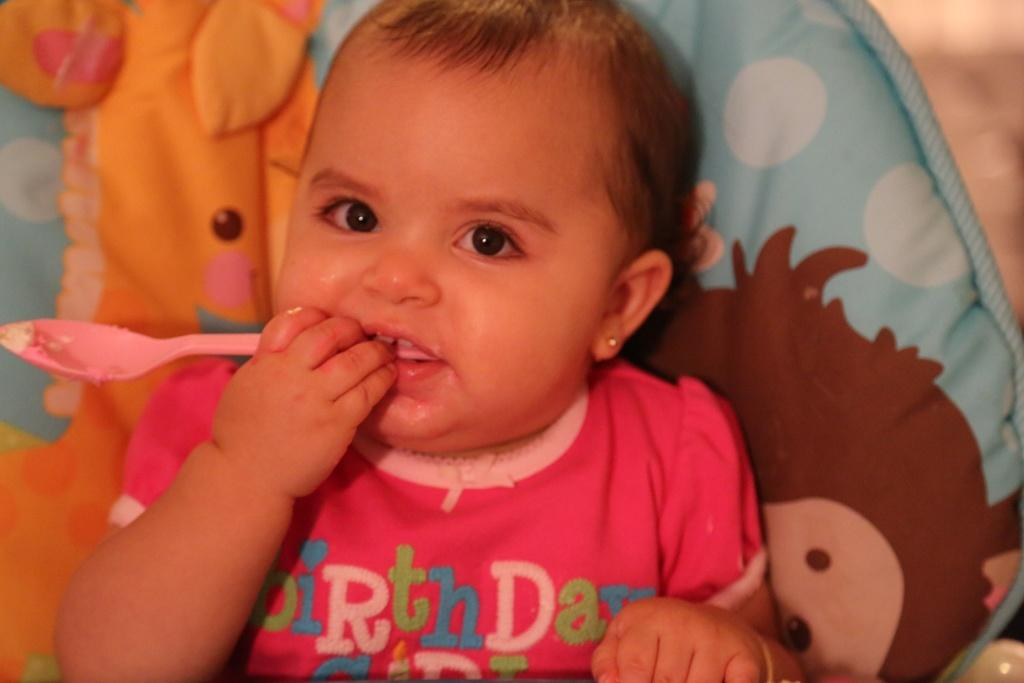What object is present in the image that is not a person? There is a cloth in the image. Who is present in the image? There is a girl in the image. What is the girl holding in her hand? The girl is holding a spoon in her hand. How would you describe the background of the image? The background of the image is blurry. What type of noise can be heard coming from the girl's legs in the image? There is no noise coming from the girl's legs in the image, and her legs are not mentioned in the provided facts. What type of canvas is visible in the image? There is no canvas present in the image. 